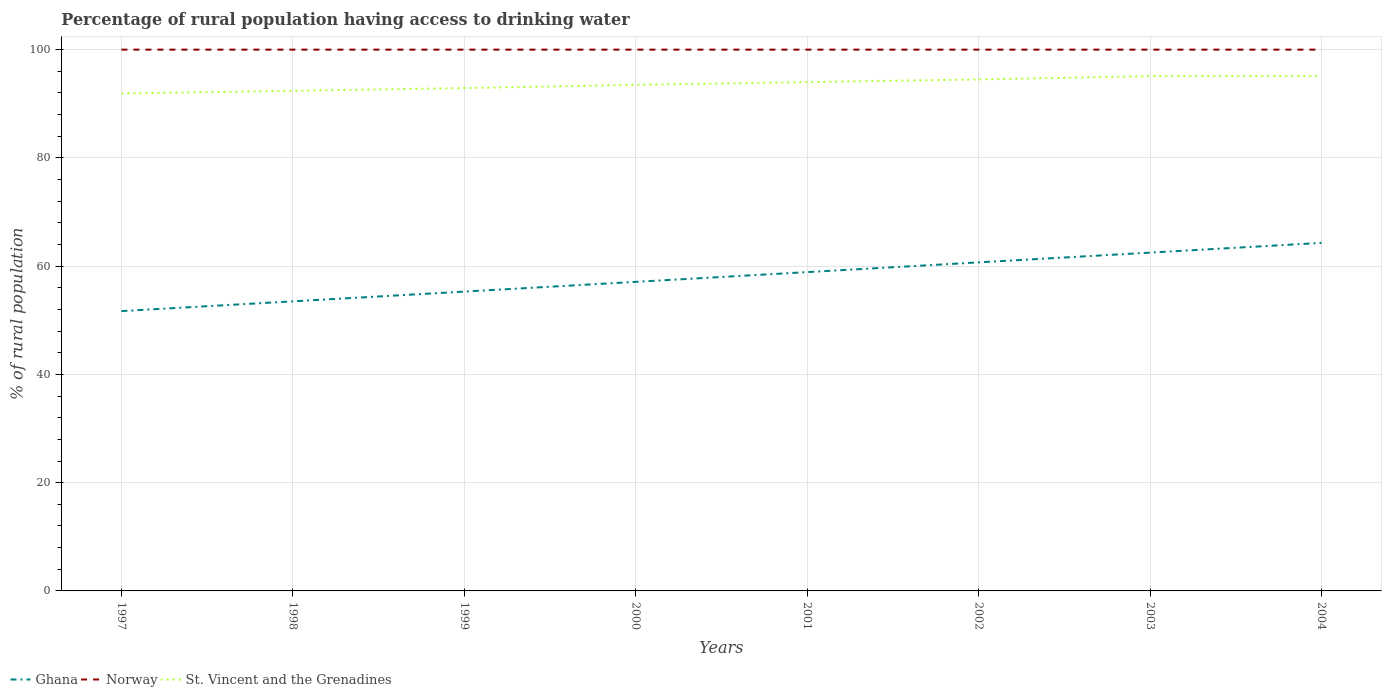How many different coloured lines are there?
Your answer should be compact. 3. Does the line corresponding to St. Vincent and the Grenadines intersect with the line corresponding to Ghana?
Your answer should be very brief. No. Across all years, what is the maximum percentage of rural population having access to drinking water in Norway?
Your response must be concise. 100. What is the difference between the highest and the second highest percentage of rural population having access to drinking water in Ghana?
Your answer should be compact. 12.6. Is the percentage of rural population having access to drinking water in St. Vincent and the Grenadines strictly greater than the percentage of rural population having access to drinking water in Norway over the years?
Provide a succinct answer. Yes. How many years are there in the graph?
Offer a very short reply. 8. What is the difference between two consecutive major ticks on the Y-axis?
Give a very brief answer. 20. Does the graph contain grids?
Your answer should be compact. Yes. Where does the legend appear in the graph?
Your answer should be compact. Bottom left. How are the legend labels stacked?
Your response must be concise. Horizontal. What is the title of the graph?
Offer a terse response. Percentage of rural population having access to drinking water. What is the label or title of the Y-axis?
Offer a terse response. % of rural population. What is the % of rural population in Ghana in 1997?
Your answer should be very brief. 51.7. What is the % of rural population in St. Vincent and the Grenadines in 1997?
Your response must be concise. 91.9. What is the % of rural population in Ghana in 1998?
Offer a very short reply. 53.5. What is the % of rural population of St. Vincent and the Grenadines in 1998?
Ensure brevity in your answer.  92.4. What is the % of rural population of Ghana in 1999?
Your answer should be very brief. 55.3. What is the % of rural population of Norway in 1999?
Make the answer very short. 100. What is the % of rural population in St. Vincent and the Grenadines in 1999?
Offer a terse response. 92.9. What is the % of rural population in Ghana in 2000?
Your answer should be compact. 57.1. What is the % of rural population of St. Vincent and the Grenadines in 2000?
Your response must be concise. 93.5. What is the % of rural population of Ghana in 2001?
Provide a succinct answer. 58.9. What is the % of rural population of St. Vincent and the Grenadines in 2001?
Offer a very short reply. 94. What is the % of rural population of Ghana in 2002?
Provide a short and direct response. 60.7. What is the % of rural population in St. Vincent and the Grenadines in 2002?
Provide a short and direct response. 94.5. What is the % of rural population of Ghana in 2003?
Provide a short and direct response. 62.5. What is the % of rural population of Norway in 2003?
Keep it short and to the point. 100. What is the % of rural population of St. Vincent and the Grenadines in 2003?
Provide a succinct answer. 95.1. What is the % of rural population in Ghana in 2004?
Keep it short and to the point. 64.3. What is the % of rural population of Norway in 2004?
Offer a terse response. 100. What is the % of rural population of St. Vincent and the Grenadines in 2004?
Offer a very short reply. 95.1. Across all years, what is the maximum % of rural population in Ghana?
Provide a short and direct response. 64.3. Across all years, what is the maximum % of rural population of St. Vincent and the Grenadines?
Your response must be concise. 95.1. Across all years, what is the minimum % of rural population in Ghana?
Offer a very short reply. 51.7. Across all years, what is the minimum % of rural population of Norway?
Ensure brevity in your answer.  100. Across all years, what is the minimum % of rural population of St. Vincent and the Grenadines?
Provide a succinct answer. 91.9. What is the total % of rural population of Ghana in the graph?
Provide a short and direct response. 464. What is the total % of rural population of Norway in the graph?
Make the answer very short. 800. What is the total % of rural population of St. Vincent and the Grenadines in the graph?
Your answer should be compact. 749.4. What is the difference between the % of rural population in Ghana in 1997 and that in 1998?
Keep it short and to the point. -1.8. What is the difference between the % of rural population in Norway in 1997 and that in 1998?
Give a very brief answer. 0. What is the difference between the % of rural population of Norway in 1997 and that in 2000?
Offer a terse response. 0. What is the difference between the % of rural population in St. Vincent and the Grenadines in 1997 and that in 2000?
Give a very brief answer. -1.6. What is the difference between the % of rural population of Ghana in 1997 and that in 2001?
Give a very brief answer. -7.2. What is the difference between the % of rural population of St. Vincent and the Grenadines in 1997 and that in 2001?
Provide a short and direct response. -2.1. What is the difference between the % of rural population of Ghana in 1997 and that in 2003?
Ensure brevity in your answer.  -10.8. What is the difference between the % of rural population of Norway in 1997 and that in 2003?
Ensure brevity in your answer.  0. What is the difference between the % of rural population in St. Vincent and the Grenadines in 1997 and that in 2004?
Your answer should be compact. -3.2. What is the difference between the % of rural population in Ghana in 1998 and that in 1999?
Ensure brevity in your answer.  -1.8. What is the difference between the % of rural population in Norway in 1998 and that in 1999?
Keep it short and to the point. 0. What is the difference between the % of rural population in St. Vincent and the Grenadines in 1998 and that in 1999?
Make the answer very short. -0.5. What is the difference between the % of rural population of St. Vincent and the Grenadines in 1998 and that in 2000?
Give a very brief answer. -1.1. What is the difference between the % of rural population in Norway in 1998 and that in 2001?
Provide a short and direct response. 0. What is the difference between the % of rural population in Norway in 1998 and that in 2003?
Offer a terse response. 0. What is the difference between the % of rural population of St. Vincent and the Grenadines in 1998 and that in 2003?
Offer a terse response. -2.7. What is the difference between the % of rural population in Ghana in 1998 and that in 2004?
Offer a very short reply. -10.8. What is the difference between the % of rural population in Norway in 1998 and that in 2004?
Provide a succinct answer. 0. What is the difference between the % of rural population in Ghana in 1999 and that in 2000?
Provide a succinct answer. -1.8. What is the difference between the % of rural population in Norway in 1999 and that in 2000?
Provide a succinct answer. 0. What is the difference between the % of rural population in St. Vincent and the Grenadines in 1999 and that in 2000?
Your answer should be very brief. -0.6. What is the difference between the % of rural population of Ghana in 1999 and that in 2001?
Provide a succinct answer. -3.6. What is the difference between the % of rural population in St. Vincent and the Grenadines in 1999 and that in 2001?
Make the answer very short. -1.1. What is the difference between the % of rural population in Norway in 1999 and that in 2002?
Provide a short and direct response. 0. What is the difference between the % of rural population of St. Vincent and the Grenadines in 1999 and that in 2002?
Ensure brevity in your answer.  -1.6. What is the difference between the % of rural population of Norway in 1999 and that in 2003?
Your answer should be compact. 0. What is the difference between the % of rural population in St. Vincent and the Grenadines in 1999 and that in 2003?
Provide a short and direct response. -2.2. What is the difference between the % of rural population of St. Vincent and the Grenadines in 1999 and that in 2004?
Make the answer very short. -2.2. What is the difference between the % of rural population of Ghana in 2000 and that in 2001?
Your answer should be compact. -1.8. What is the difference between the % of rural population in Norway in 2000 and that in 2001?
Keep it short and to the point. 0. What is the difference between the % of rural population of St. Vincent and the Grenadines in 2000 and that in 2001?
Offer a terse response. -0.5. What is the difference between the % of rural population in Norway in 2000 and that in 2002?
Give a very brief answer. 0. What is the difference between the % of rural population of Ghana in 2000 and that in 2003?
Make the answer very short. -5.4. What is the difference between the % of rural population in Norway in 2000 and that in 2003?
Your response must be concise. 0. What is the difference between the % of rural population of St. Vincent and the Grenadines in 2000 and that in 2004?
Your response must be concise. -1.6. What is the difference between the % of rural population in St. Vincent and the Grenadines in 2001 and that in 2002?
Your answer should be very brief. -0.5. What is the difference between the % of rural population in Ghana in 2001 and that in 2003?
Provide a succinct answer. -3.6. What is the difference between the % of rural population of Norway in 2001 and that in 2004?
Make the answer very short. 0. What is the difference between the % of rural population of Ghana in 2002 and that in 2003?
Give a very brief answer. -1.8. What is the difference between the % of rural population of Norway in 2002 and that in 2003?
Your answer should be compact. 0. What is the difference between the % of rural population in St. Vincent and the Grenadines in 2002 and that in 2004?
Offer a very short reply. -0.6. What is the difference between the % of rural population in Norway in 2003 and that in 2004?
Provide a short and direct response. 0. What is the difference between the % of rural population of St. Vincent and the Grenadines in 2003 and that in 2004?
Offer a very short reply. 0. What is the difference between the % of rural population of Ghana in 1997 and the % of rural population of Norway in 1998?
Make the answer very short. -48.3. What is the difference between the % of rural population of Ghana in 1997 and the % of rural population of St. Vincent and the Grenadines in 1998?
Provide a succinct answer. -40.7. What is the difference between the % of rural population of Norway in 1997 and the % of rural population of St. Vincent and the Grenadines in 1998?
Give a very brief answer. 7.6. What is the difference between the % of rural population of Ghana in 1997 and the % of rural population of Norway in 1999?
Offer a terse response. -48.3. What is the difference between the % of rural population in Ghana in 1997 and the % of rural population in St. Vincent and the Grenadines in 1999?
Keep it short and to the point. -41.2. What is the difference between the % of rural population of Ghana in 1997 and the % of rural population of Norway in 2000?
Provide a succinct answer. -48.3. What is the difference between the % of rural population of Ghana in 1997 and the % of rural population of St. Vincent and the Grenadines in 2000?
Provide a short and direct response. -41.8. What is the difference between the % of rural population in Ghana in 1997 and the % of rural population in Norway in 2001?
Provide a succinct answer. -48.3. What is the difference between the % of rural population in Ghana in 1997 and the % of rural population in St. Vincent and the Grenadines in 2001?
Offer a very short reply. -42.3. What is the difference between the % of rural population in Norway in 1997 and the % of rural population in St. Vincent and the Grenadines in 2001?
Ensure brevity in your answer.  6. What is the difference between the % of rural population in Ghana in 1997 and the % of rural population in Norway in 2002?
Offer a terse response. -48.3. What is the difference between the % of rural population in Ghana in 1997 and the % of rural population in St. Vincent and the Grenadines in 2002?
Provide a succinct answer. -42.8. What is the difference between the % of rural population in Norway in 1997 and the % of rural population in St. Vincent and the Grenadines in 2002?
Your answer should be compact. 5.5. What is the difference between the % of rural population in Ghana in 1997 and the % of rural population in Norway in 2003?
Keep it short and to the point. -48.3. What is the difference between the % of rural population of Ghana in 1997 and the % of rural population of St. Vincent and the Grenadines in 2003?
Keep it short and to the point. -43.4. What is the difference between the % of rural population in Norway in 1997 and the % of rural population in St. Vincent and the Grenadines in 2003?
Offer a terse response. 4.9. What is the difference between the % of rural population of Ghana in 1997 and the % of rural population of Norway in 2004?
Your answer should be very brief. -48.3. What is the difference between the % of rural population in Ghana in 1997 and the % of rural population in St. Vincent and the Grenadines in 2004?
Ensure brevity in your answer.  -43.4. What is the difference between the % of rural population in Norway in 1997 and the % of rural population in St. Vincent and the Grenadines in 2004?
Provide a succinct answer. 4.9. What is the difference between the % of rural population of Ghana in 1998 and the % of rural population of Norway in 1999?
Your response must be concise. -46.5. What is the difference between the % of rural population of Ghana in 1998 and the % of rural population of St. Vincent and the Grenadines in 1999?
Keep it short and to the point. -39.4. What is the difference between the % of rural population of Norway in 1998 and the % of rural population of St. Vincent and the Grenadines in 1999?
Give a very brief answer. 7.1. What is the difference between the % of rural population in Ghana in 1998 and the % of rural population in Norway in 2000?
Your response must be concise. -46.5. What is the difference between the % of rural population of Norway in 1998 and the % of rural population of St. Vincent and the Grenadines in 2000?
Provide a succinct answer. 6.5. What is the difference between the % of rural population of Ghana in 1998 and the % of rural population of Norway in 2001?
Give a very brief answer. -46.5. What is the difference between the % of rural population in Ghana in 1998 and the % of rural population in St. Vincent and the Grenadines in 2001?
Provide a succinct answer. -40.5. What is the difference between the % of rural population of Ghana in 1998 and the % of rural population of Norway in 2002?
Keep it short and to the point. -46.5. What is the difference between the % of rural population of Ghana in 1998 and the % of rural population of St. Vincent and the Grenadines in 2002?
Your response must be concise. -41. What is the difference between the % of rural population of Norway in 1998 and the % of rural population of St. Vincent and the Grenadines in 2002?
Provide a short and direct response. 5.5. What is the difference between the % of rural population in Ghana in 1998 and the % of rural population in Norway in 2003?
Provide a succinct answer. -46.5. What is the difference between the % of rural population of Ghana in 1998 and the % of rural population of St. Vincent and the Grenadines in 2003?
Make the answer very short. -41.6. What is the difference between the % of rural population of Ghana in 1998 and the % of rural population of Norway in 2004?
Your response must be concise. -46.5. What is the difference between the % of rural population in Ghana in 1998 and the % of rural population in St. Vincent and the Grenadines in 2004?
Make the answer very short. -41.6. What is the difference between the % of rural population of Ghana in 1999 and the % of rural population of Norway in 2000?
Give a very brief answer. -44.7. What is the difference between the % of rural population in Ghana in 1999 and the % of rural population in St. Vincent and the Grenadines in 2000?
Your answer should be compact. -38.2. What is the difference between the % of rural population of Ghana in 1999 and the % of rural population of Norway in 2001?
Ensure brevity in your answer.  -44.7. What is the difference between the % of rural population of Ghana in 1999 and the % of rural population of St. Vincent and the Grenadines in 2001?
Your answer should be compact. -38.7. What is the difference between the % of rural population in Ghana in 1999 and the % of rural population in Norway in 2002?
Your response must be concise. -44.7. What is the difference between the % of rural population of Ghana in 1999 and the % of rural population of St. Vincent and the Grenadines in 2002?
Ensure brevity in your answer.  -39.2. What is the difference between the % of rural population of Norway in 1999 and the % of rural population of St. Vincent and the Grenadines in 2002?
Keep it short and to the point. 5.5. What is the difference between the % of rural population of Ghana in 1999 and the % of rural population of Norway in 2003?
Provide a succinct answer. -44.7. What is the difference between the % of rural population in Ghana in 1999 and the % of rural population in St. Vincent and the Grenadines in 2003?
Your answer should be compact. -39.8. What is the difference between the % of rural population in Ghana in 1999 and the % of rural population in Norway in 2004?
Provide a short and direct response. -44.7. What is the difference between the % of rural population in Ghana in 1999 and the % of rural population in St. Vincent and the Grenadines in 2004?
Provide a succinct answer. -39.8. What is the difference between the % of rural population in Norway in 1999 and the % of rural population in St. Vincent and the Grenadines in 2004?
Offer a very short reply. 4.9. What is the difference between the % of rural population of Ghana in 2000 and the % of rural population of Norway in 2001?
Offer a terse response. -42.9. What is the difference between the % of rural population of Ghana in 2000 and the % of rural population of St. Vincent and the Grenadines in 2001?
Provide a short and direct response. -36.9. What is the difference between the % of rural population in Norway in 2000 and the % of rural population in St. Vincent and the Grenadines in 2001?
Offer a very short reply. 6. What is the difference between the % of rural population in Ghana in 2000 and the % of rural population in Norway in 2002?
Offer a very short reply. -42.9. What is the difference between the % of rural population of Ghana in 2000 and the % of rural population of St. Vincent and the Grenadines in 2002?
Offer a terse response. -37.4. What is the difference between the % of rural population of Norway in 2000 and the % of rural population of St. Vincent and the Grenadines in 2002?
Provide a short and direct response. 5.5. What is the difference between the % of rural population in Ghana in 2000 and the % of rural population in Norway in 2003?
Keep it short and to the point. -42.9. What is the difference between the % of rural population of Ghana in 2000 and the % of rural population of St. Vincent and the Grenadines in 2003?
Your response must be concise. -38. What is the difference between the % of rural population in Ghana in 2000 and the % of rural population in Norway in 2004?
Make the answer very short. -42.9. What is the difference between the % of rural population in Ghana in 2000 and the % of rural population in St. Vincent and the Grenadines in 2004?
Ensure brevity in your answer.  -38. What is the difference between the % of rural population in Ghana in 2001 and the % of rural population in Norway in 2002?
Your answer should be very brief. -41.1. What is the difference between the % of rural population in Ghana in 2001 and the % of rural population in St. Vincent and the Grenadines in 2002?
Make the answer very short. -35.6. What is the difference between the % of rural population in Norway in 2001 and the % of rural population in St. Vincent and the Grenadines in 2002?
Your answer should be very brief. 5.5. What is the difference between the % of rural population of Ghana in 2001 and the % of rural population of Norway in 2003?
Give a very brief answer. -41.1. What is the difference between the % of rural population in Ghana in 2001 and the % of rural population in St. Vincent and the Grenadines in 2003?
Provide a succinct answer. -36.2. What is the difference between the % of rural population of Ghana in 2001 and the % of rural population of Norway in 2004?
Offer a terse response. -41.1. What is the difference between the % of rural population of Ghana in 2001 and the % of rural population of St. Vincent and the Grenadines in 2004?
Give a very brief answer. -36.2. What is the difference between the % of rural population in Ghana in 2002 and the % of rural population in Norway in 2003?
Your response must be concise. -39.3. What is the difference between the % of rural population of Ghana in 2002 and the % of rural population of St. Vincent and the Grenadines in 2003?
Provide a short and direct response. -34.4. What is the difference between the % of rural population in Ghana in 2002 and the % of rural population in Norway in 2004?
Offer a very short reply. -39.3. What is the difference between the % of rural population of Ghana in 2002 and the % of rural population of St. Vincent and the Grenadines in 2004?
Make the answer very short. -34.4. What is the difference between the % of rural population of Ghana in 2003 and the % of rural population of Norway in 2004?
Your answer should be compact. -37.5. What is the difference between the % of rural population of Ghana in 2003 and the % of rural population of St. Vincent and the Grenadines in 2004?
Your answer should be compact. -32.6. What is the difference between the % of rural population in Norway in 2003 and the % of rural population in St. Vincent and the Grenadines in 2004?
Your answer should be very brief. 4.9. What is the average % of rural population in Ghana per year?
Your answer should be compact. 58. What is the average % of rural population of St. Vincent and the Grenadines per year?
Offer a very short reply. 93.67. In the year 1997, what is the difference between the % of rural population of Ghana and % of rural population of Norway?
Your response must be concise. -48.3. In the year 1997, what is the difference between the % of rural population in Ghana and % of rural population in St. Vincent and the Grenadines?
Provide a succinct answer. -40.2. In the year 1997, what is the difference between the % of rural population in Norway and % of rural population in St. Vincent and the Grenadines?
Provide a succinct answer. 8.1. In the year 1998, what is the difference between the % of rural population in Ghana and % of rural population in Norway?
Offer a terse response. -46.5. In the year 1998, what is the difference between the % of rural population in Ghana and % of rural population in St. Vincent and the Grenadines?
Offer a terse response. -38.9. In the year 1999, what is the difference between the % of rural population in Ghana and % of rural population in Norway?
Offer a very short reply. -44.7. In the year 1999, what is the difference between the % of rural population of Ghana and % of rural population of St. Vincent and the Grenadines?
Your response must be concise. -37.6. In the year 2000, what is the difference between the % of rural population of Ghana and % of rural population of Norway?
Offer a very short reply. -42.9. In the year 2000, what is the difference between the % of rural population in Ghana and % of rural population in St. Vincent and the Grenadines?
Make the answer very short. -36.4. In the year 2001, what is the difference between the % of rural population of Ghana and % of rural population of Norway?
Your answer should be very brief. -41.1. In the year 2001, what is the difference between the % of rural population of Ghana and % of rural population of St. Vincent and the Grenadines?
Give a very brief answer. -35.1. In the year 2002, what is the difference between the % of rural population in Ghana and % of rural population in Norway?
Your response must be concise. -39.3. In the year 2002, what is the difference between the % of rural population in Ghana and % of rural population in St. Vincent and the Grenadines?
Offer a terse response. -33.8. In the year 2002, what is the difference between the % of rural population in Norway and % of rural population in St. Vincent and the Grenadines?
Your answer should be very brief. 5.5. In the year 2003, what is the difference between the % of rural population in Ghana and % of rural population in Norway?
Your answer should be compact. -37.5. In the year 2003, what is the difference between the % of rural population in Ghana and % of rural population in St. Vincent and the Grenadines?
Your answer should be very brief. -32.6. In the year 2003, what is the difference between the % of rural population of Norway and % of rural population of St. Vincent and the Grenadines?
Ensure brevity in your answer.  4.9. In the year 2004, what is the difference between the % of rural population in Ghana and % of rural population in Norway?
Your answer should be very brief. -35.7. In the year 2004, what is the difference between the % of rural population of Ghana and % of rural population of St. Vincent and the Grenadines?
Your response must be concise. -30.8. In the year 2004, what is the difference between the % of rural population of Norway and % of rural population of St. Vincent and the Grenadines?
Keep it short and to the point. 4.9. What is the ratio of the % of rural population of Ghana in 1997 to that in 1998?
Ensure brevity in your answer.  0.97. What is the ratio of the % of rural population of Ghana in 1997 to that in 1999?
Keep it short and to the point. 0.93. What is the ratio of the % of rural population of Norway in 1997 to that in 1999?
Provide a short and direct response. 1. What is the ratio of the % of rural population in St. Vincent and the Grenadines in 1997 to that in 1999?
Your response must be concise. 0.99. What is the ratio of the % of rural population of Ghana in 1997 to that in 2000?
Ensure brevity in your answer.  0.91. What is the ratio of the % of rural population of St. Vincent and the Grenadines in 1997 to that in 2000?
Your answer should be very brief. 0.98. What is the ratio of the % of rural population in Ghana in 1997 to that in 2001?
Ensure brevity in your answer.  0.88. What is the ratio of the % of rural population of St. Vincent and the Grenadines in 1997 to that in 2001?
Your answer should be very brief. 0.98. What is the ratio of the % of rural population in Ghana in 1997 to that in 2002?
Your answer should be very brief. 0.85. What is the ratio of the % of rural population in Norway in 1997 to that in 2002?
Keep it short and to the point. 1. What is the ratio of the % of rural population in St. Vincent and the Grenadines in 1997 to that in 2002?
Offer a terse response. 0.97. What is the ratio of the % of rural population in Ghana in 1997 to that in 2003?
Your answer should be compact. 0.83. What is the ratio of the % of rural population of St. Vincent and the Grenadines in 1997 to that in 2003?
Give a very brief answer. 0.97. What is the ratio of the % of rural population of Ghana in 1997 to that in 2004?
Keep it short and to the point. 0.8. What is the ratio of the % of rural population in Norway in 1997 to that in 2004?
Ensure brevity in your answer.  1. What is the ratio of the % of rural population of St. Vincent and the Grenadines in 1997 to that in 2004?
Your response must be concise. 0.97. What is the ratio of the % of rural population of Ghana in 1998 to that in 1999?
Keep it short and to the point. 0.97. What is the ratio of the % of rural population of St. Vincent and the Grenadines in 1998 to that in 1999?
Offer a terse response. 0.99. What is the ratio of the % of rural population in Ghana in 1998 to that in 2000?
Provide a short and direct response. 0.94. What is the ratio of the % of rural population of Ghana in 1998 to that in 2001?
Offer a terse response. 0.91. What is the ratio of the % of rural population of Norway in 1998 to that in 2001?
Your answer should be very brief. 1. What is the ratio of the % of rural population in Ghana in 1998 to that in 2002?
Provide a short and direct response. 0.88. What is the ratio of the % of rural population of Norway in 1998 to that in 2002?
Your response must be concise. 1. What is the ratio of the % of rural population of St. Vincent and the Grenadines in 1998 to that in 2002?
Your answer should be very brief. 0.98. What is the ratio of the % of rural population of Ghana in 1998 to that in 2003?
Keep it short and to the point. 0.86. What is the ratio of the % of rural population of St. Vincent and the Grenadines in 1998 to that in 2003?
Offer a very short reply. 0.97. What is the ratio of the % of rural population in Ghana in 1998 to that in 2004?
Keep it short and to the point. 0.83. What is the ratio of the % of rural population of Norway in 1998 to that in 2004?
Provide a short and direct response. 1. What is the ratio of the % of rural population of St. Vincent and the Grenadines in 1998 to that in 2004?
Ensure brevity in your answer.  0.97. What is the ratio of the % of rural population of Ghana in 1999 to that in 2000?
Provide a succinct answer. 0.97. What is the ratio of the % of rural population in Norway in 1999 to that in 2000?
Provide a succinct answer. 1. What is the ratio of the % of rural population of Ghana in 1999 to that in 2001?
Your answer should be compact. 0.94. What is the ratio of the % of rural population of Norway in 1999 to that in 2001?
Give a very brief answer. 1. What is the ratio of the % of rural population in St. Vincent and the Grenadines in 1999 to that in 2001?
Provide a short and direct response. 0.99. What is the ratio of the % of rural population of Ghana in 1999 to that in 2002?
Ensure brevity in your answer.  0.91. What is the ratio of the % of rural population in Norway in 1999 to that in 2002?
Your answer should be very brief. 1. What is the ratio of the % of rural population of St. Vincent and the Grenadines in 1999 to that in 2002?
Provide a succinct answer. 0.98. What is the ratio of the % of rural population in Ghana in 1999 to that in 2003?
Make the answer very short. 0.88. What is the ratio of the % of rural population in St. Vincent and the Grenadines in 1999 to that in 2003?
Your answer should be very brief. 0.98. What is the ratio of the % of rural population in Ghana in 1999 to that in 2004?
Offer a very short reply. 0.86. What is the ratio of the % of rural population in Norway in 1999 to that in 2004?
Keep it short and to the point. 1. What is the ratio of the % of rural population of St. Vincent and the Grenadines in 1999 to that in 2004?
Your answer should be compact. 0.98. What is the ratio of the % of rural population in Ghana in 2000 to that in 2001?
Keep it short and to the point. 0.97. What is the ratio of the % of rural population of Norway in 2000 to that in 2001?
Your response must be concise. 1. What is the ratio of the % of rural population of Ghana in 2000 to that in 2002?
Give a very brief answer. 0.94. What is the ratio of the % of rural population of St. Vincent and the Grenadines in 2000 to that in 2002?
Provide a short and direct response. 0.99. What is the ratio of the % of rural population in Ghana in 2000 to that in 2003?
Make the answer very short. 0.91. What is the ratio of the % of rural population in St. Vincent and the Grenadines in 2000 to that in 2003?
Your answer should be compact. 0.98. What is the ratio of the % of rural population in Ghana in 2000 to that in 2004?
Offer a very short reply. 0.89. What is the ratio of the % of rural population in St. Vincent and the Grenadines in 2000 to that in 2004?
Give a very brief answer. 0.98. What is the ratio of the % of rural population of Ghana in 2001 to that in 2002?
Provide a succinct answer. 0.97. What is the ratio of the % of rural population in Norway in 2001 to that in 2002?
Your response must be concise. 1. What is the ratio of the % of rural population in St. Vincent and the Grenadines in 2001 to that in 2002?
Your response must be concise. 0.99. What is the ratio of the % of rural population in Ghana in 2001 to that in 2003?
Provide a succinct answer. 0.94. What is the ratio of the % of rural population of St. Vincent and the Grenadines in 2001 to that in 2003?
Make the answer very short. 0.99. What is the ratio of the % of rural population of Ghana in 2001 to that in 2004?
Keep it short and to the point. 0.92. What is the ratio of the % of rural population in Norway in 2001 to that in 2004?
Offer a very short reply. 1. What is the ratio of the % of rural population of St. Vincent and the Grenadines in 2001 to that in 2004?
Offer a terse response. 0.99. What is the ratio of the % of rural population in Ghana in 2002 to that in 2003?
Provide a succinct answer. 0.97. What is the ratio of the % of rural population of Ghana in 2002 to that in 2004?
Keep it short and to the point. 0.94. What is the ratio of the % of rural population in St. Vincent and the Grenadines in 2002 to that in 2004?
Make the answer very short. 0.99. What is the ratio of the % of rural population in Ghana in 2003 to that in 2004?
Give a very brief answer. 0.97. What is the difference between the highest and the lowest % of rural population in Norway?
Offer a very short reply. 0. 